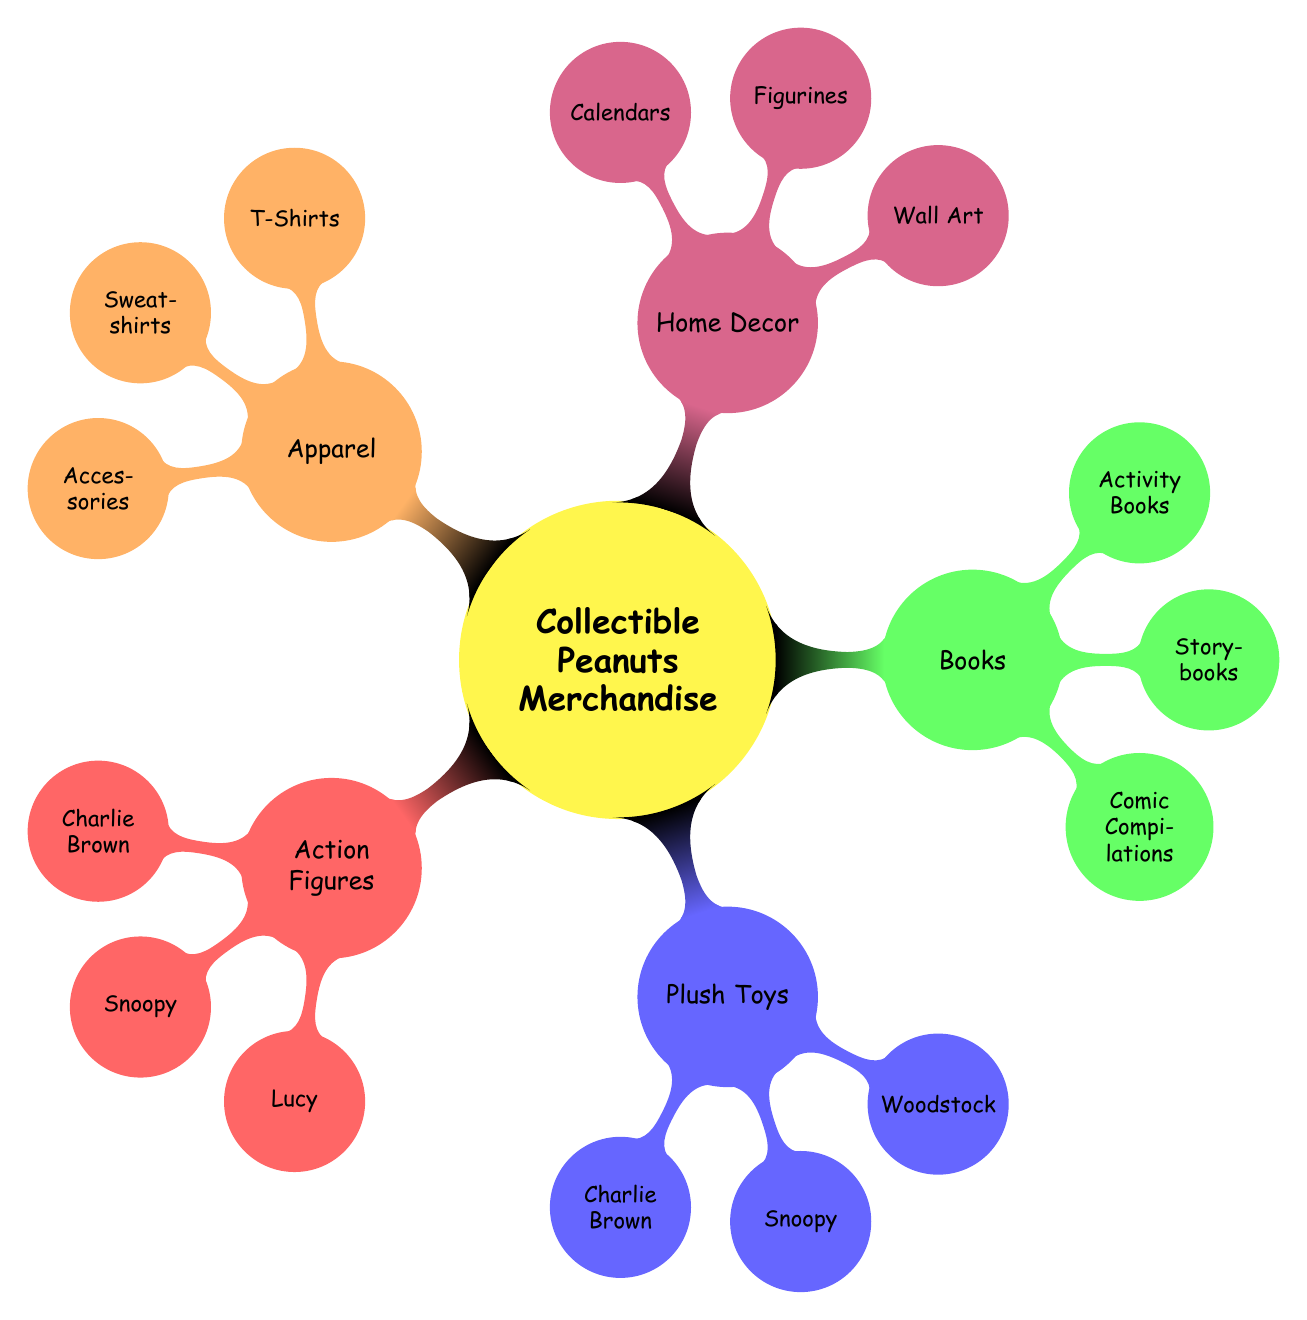What are the categories of collectible Peanuts merchandise? The diagram displays five main categories of collectible Peanuts merchandise: Action Figures, Plush Toys, Books, Home Decor, and Apparel.
Answer: Action Figures, Plush Toys, Books, Home Decor, Apparel How many characters are represented in Action Figures? Within the Action Figures category, there are three characters: Charlie Brown, Snoopy, and Lucy.
Answer: 3 Which merchandise category includes "Happiness is a Warm Blanket, Charlie Brown"? "Happiness is a Warm Blanket, Charlie Brown" is located under the Storybooks node, which falls under the Books category.
Answer: Books What is the color associated with the Home Decor category? In the diagram, the Home Decor category is represented by the color purple.
Answer: Purple Which character has a plush toy as part of the Collectible Peanuts Merchandise? The Plush Toys category contains plush toys for Charlie Brown, Snoopy, and Woodstock.
Answer: Charlie Brown, Snoopy, Woodstock What is the relationship between Plush Toys and Charlie Brown? Charlie Brown is one of the nodes under the Plush Toys category indicating that there is a specific plush toy for him.
Answer: Plush Toys → Charlie Brown What is the total number of nodes under the Apparel category? The Apparel category consists of three nodes: T-Shirts, Sweatshirts, and Accessories, leading to a total of three nodes.
Answer: 3 Which category contains the Jim Shore Peanuts Collectible Figurines? The Jim Shore Peanuts Collectible Figurines are found under the Home Decor category, specifically in the Figurines node.
Answer: Home Decor Name one item listed under the Books category. The diagram highlights several items under the Books category, including Comic Compilations, which contain The Complete Peanuts, indicating a specific title.
Answer: The Complete Peanuts 